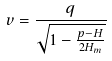Convert formula to latex. <formula><loc_0><loc_0><loc_500><loc_500>v = \frac { q } { \sqrt { 1 - \frac { p - H } { 2 H _ { m } } } }</formula> 